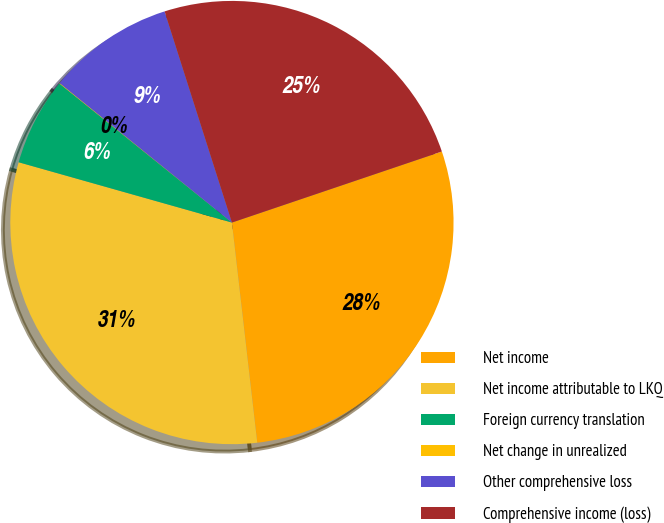<chart> <loc_0><loc_0><loc_500><loc_500><pie_chart><fcel>Net income<fcel>Net income attributable to LKQ<fcel>Foreign currency translation<fcel>Net change in unrealized<fcel>Other comprehensive loss<fcel>Comprehensive income (loss)<nl><fcel>28.37%<fcel>31.21%<fcel>6.41%<fcel>0.04%<fcel>9.25%<fcel>24.72%<nl></chart> 